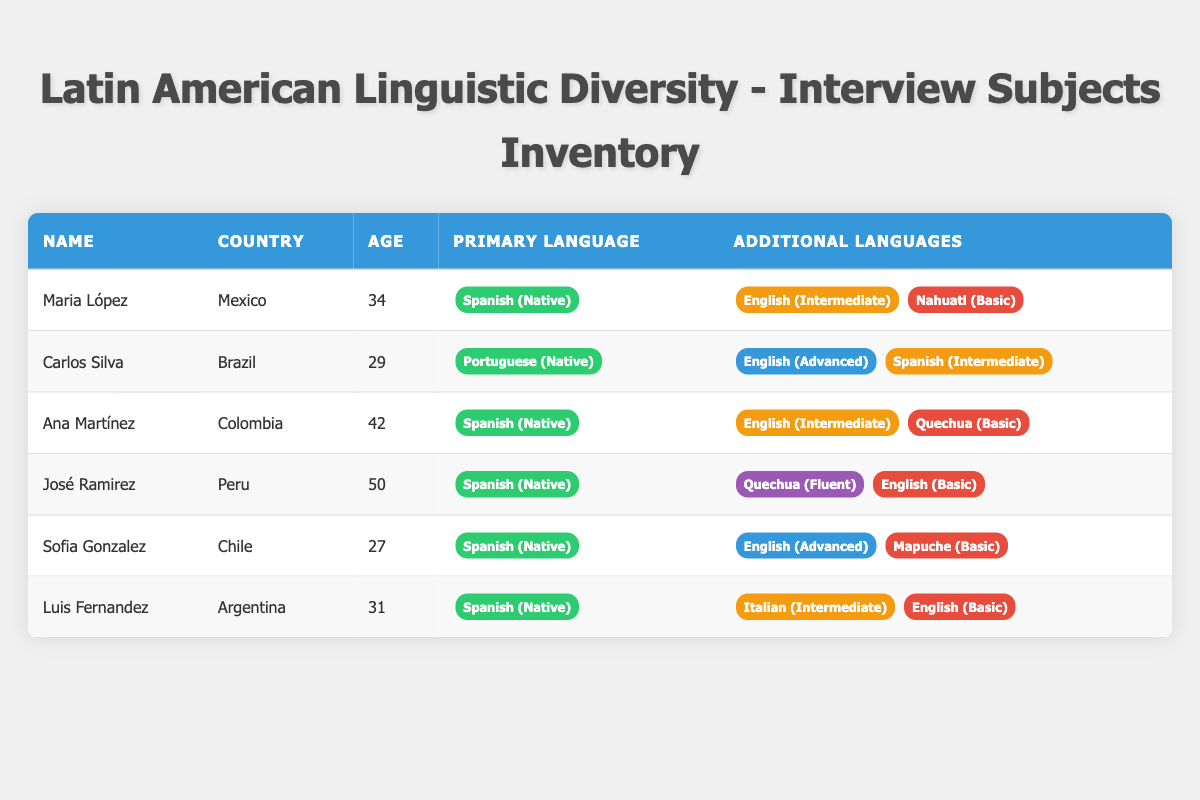What is the primary language of José Ramirez? The table shows that José Ramirez's primary language is listed in the "Primary Language" column, which indicates he speaks Spanish (Native).
Answer: Spanish (Native) How many interview subjects speak English at an advanced proficiency level? By examining the "Additional Languages" for each subject, Carlos Silva and Sofia Gonzalez are noted to speak English at an advanced level, totaling two subjects.
Answer: 2 Which country has the oldest interview subject? To find the oldest interview subject, we look at the "Age" column and identify that José Ramirez, at 50 years old, is the oldest subject.
Answer: Peru Is Maria López proficient in Nahuatl? The table lists Maria López's additional languages and her proficiency in Nahuatl, which is categorized as basic, confirming her proficiency.
Answer: Yes What is the average age of the interview subjects who are native Spanish speakers? The native Spanish speakers are Maria López, Ana Martínez, José Ramirez, Sofia Gonzalez, and Luis Fernandez. Their ages (34, 42, 50, 27, and 31, respectively) add up to 184, and dividing by 5 yields an average age of 36.8.
Answer: 36.8 How many additional languages does Carlos Silva speak compared to Luis Fernandez? Carlos Silva speaks two additional languages (English and Spanish), while Luis Fernandez also speaks two additional languages (Italian and English). Thus, they speak the same number of additional languages.
Answer: 0 Which interview subject has the highest proficiency in Quechua? The table indicates that José Ramirez speaks Quechua at a fluent proficiency level, which is the highest among all subjects categorized in the table.
Answer: José Ramirez What language proficiency do all subjects have for their primary language? Reviewing the table, every subject listed has a native proficiency level for their primary language.
Answer: Native Which additional languages are spoken by interview subjects from Brazil? Carlos Silva is the interview subject from Brazil, and he speaks English at an advanced level and Spanish at an intermediate level as additional languages.
Answer: English (Advanced), Spanish (Intermediate) 